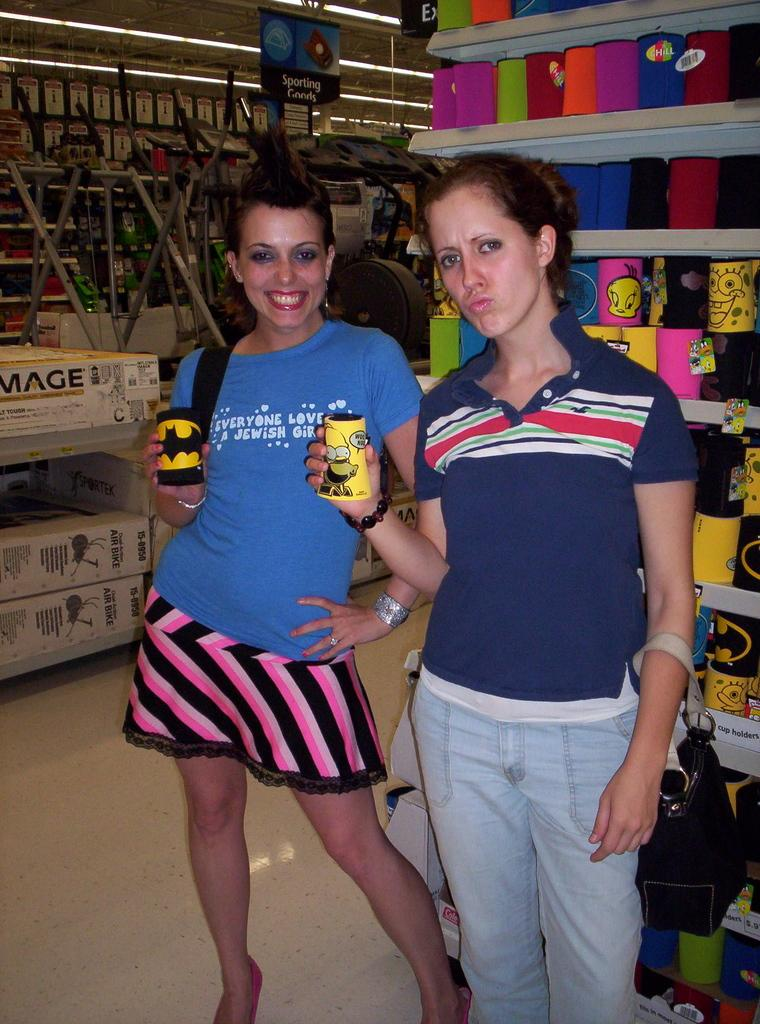Provide a one-sentence caption for the provided image. two women, one has a shirt having to do with Jewish religion on it. 